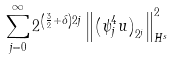Convert formula to latex. <formula><loc_0><loc_0><loc_500><loc_500>\sum _ { j = 0 } ^ { \infty } 2 ^ { \left ( \frac { 3 } { 2 } + \delta \right ) 2 j } \left \| \left ( \psi _ { j } ^ { 4 } u \right ) _ { 2 ^ { j } } \right \| _ { H ^ { s } } ^ { 2 }</formula> 